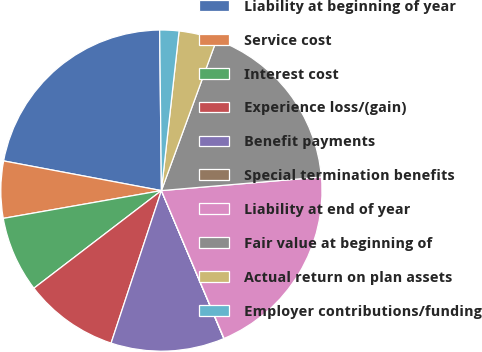Convert chart. <chart><loc_0><loc_0><loc_500><loc_500><pie_chart><fcel>Liability at beginning of year<fcel>Service cost<fcel>Interest cost<fcel>Experience loss/(gain)<fcel>Benefit payments<fcel>Special termination benefits<fcel>Liability at end of year<fcel>Fair value at beginning of<fcel>Actual return on plan assets<fcel>Employer contributions/funding<nl><fcel>21.87%<fcel>5.73%<fcel>7.63%<fcel>9.53%<fcel>11.43%<fcel>0.03%<fcel>19.97%<fcel>18.07%<fcel>3.83%<fcel>1.93%<nl></chart> 